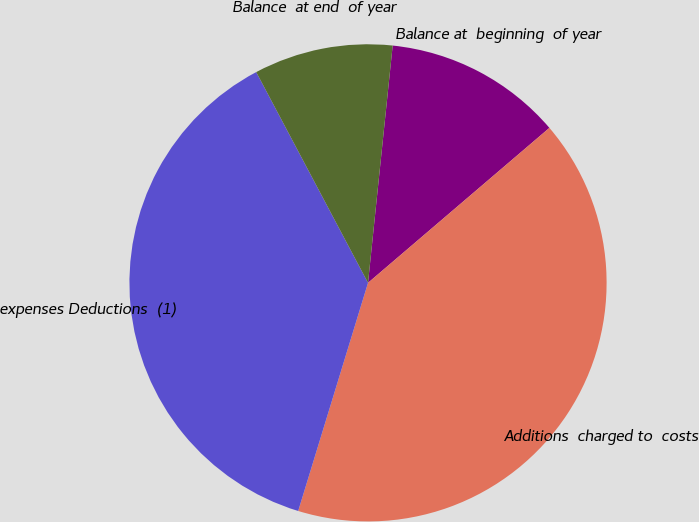Convert chart. <chart><loc_0><loc_0><loc_500><loc_500><pie_chart><fcel>Balance at  beginning  of year<fcel>Additions  charged to  costs<fcel>expenses Deductions  (1)<fcel>Balance  at end  of year<nl><fcel>12.1%<fcel>40.98%<fcel>37.51%<fcel>9.41%<nl></chart> 